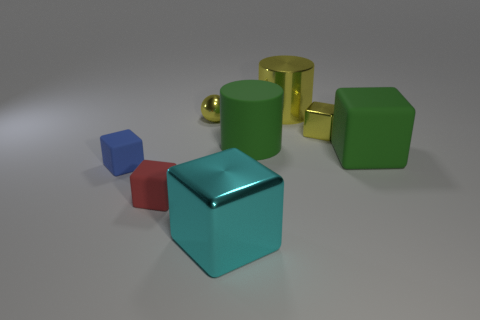What number of cylinders are either small yellow objects or small cyan rubber objects? In the image, none of the cylinders are either small yellow objects or cyan rubber objects. The cylinders present are yellow but not small, and there are no cyan rubber objects among them.  